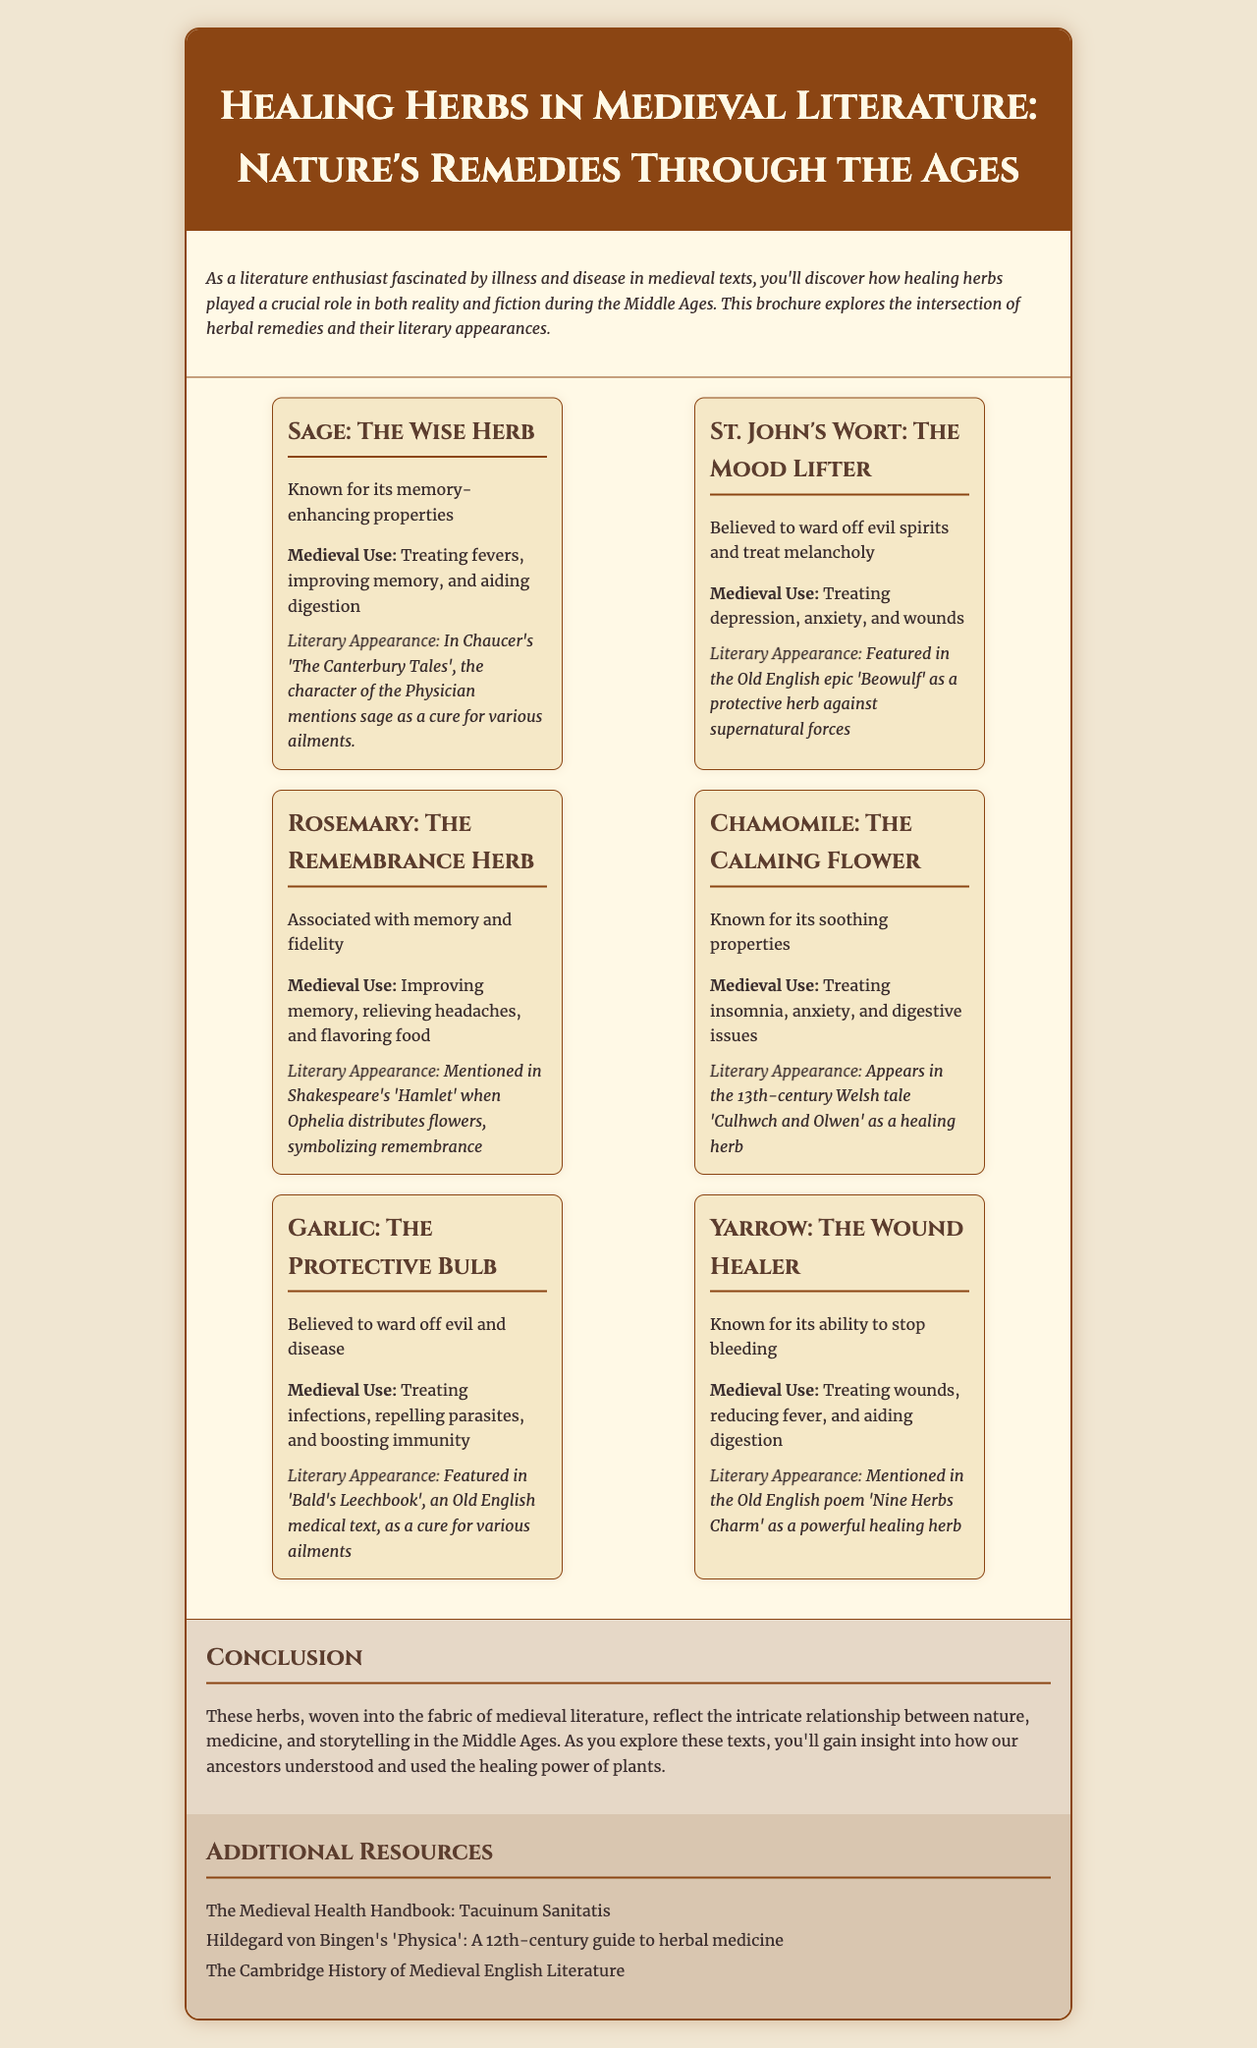What is the title of the brochure? The title is provided at the beginning of the document and identifies the subject of the brochure.
Answer: Healing Herbs in Medieval Literature: Nature's Remedies Through the Ages What literary work mentions sage? The document cites a specific literary work where sage is referenced as a healing herb.
Answer: The Canterbury Tales Name one use of St. John's Wort in medieval times. The document lists various uses for St. John's Wort during the Middle Ages.
Answer: Treating depression Which herb is associated with remembrance? The brochure describes a herb that symbolizes memory and fidelity in literature.
Answer: Rosemary What is the primary conclusion of the brochure? The conclusion summarizes the overall theme and findings presented in the brochure.
Answer: Intricate relationship between nature, medicine, and storytelling Which herb is known for stopping bleeding? The document notes a specific herb recognized for this particular healing property.
Answer: Yarrow How many herbs are featured in the brochure? The number of herbs included in the sections of the brochure can be calculated.
Answer: Six What is the first herb listed in the document? The order of the herbs is arranged in the brochure, and the first one can be easily identified.
Answer: Sage Which additional resource focuses on herbal medicine? The brochure includes educational resources, one of which covers herbal treatments.
Answer: Hildegard von Bingen's 'Physica' 